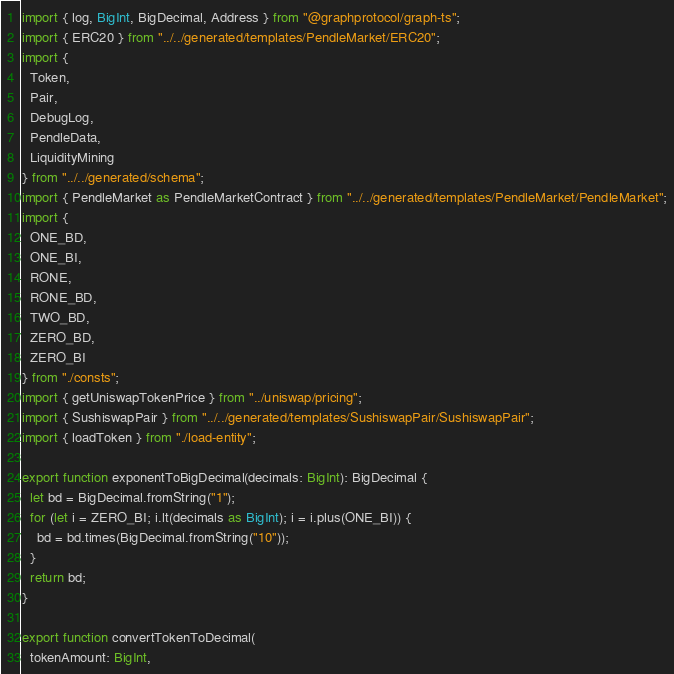<code> <loc_0><loc_0><loc_500><loc_500><_TypeScript_>import { log, BigInt, BigDecimal, Address } from "@graphprotocol/graph-ts";
import { ERC20 } from "../../generated/templates/PendleMarket/ERC20";
import {
  Token,
  Pair,
  DebugLog,
  PendleData,
  LiquidityMining
} from "../../generated/schema";
import { PendleMarket as PendleMarketContract } from "../../generated/templates/PendleMarket/PendleMarket";
import {
  ONE_BD,
  ONE_BI,
  RONE,
  RONE_BD,
  TWO_BD,
  ZERO_BD,
  ZERO_BI
} from "./consts";
import { getUniswapTokenPrice } from "../uniswap/pricing";
import { SushiswapPair } from "../../generated/templates/SushiswapPair/SushiswapPair";
import { loadToken } from "./load-entity";

export function exponentToBigDecimal(decimals: BigInt): BigDecimal {
  let bd = BigDecimal.fromString("1");
  for (let i = ZERO_BI; i.lt(decimals as BigInt); i = i.plus(ONE_BI)) {
    bd = bd.times(BigDecimal.fromString("10"));
  }
  return bd;
}

export function convertTokenToDecimal(
  tokenAmount: BigInt,</code> 